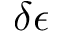Convert formula to latex. <formula><loc_0><loc_0><loc_500><loc_500>\delta \epsilon</formula> 